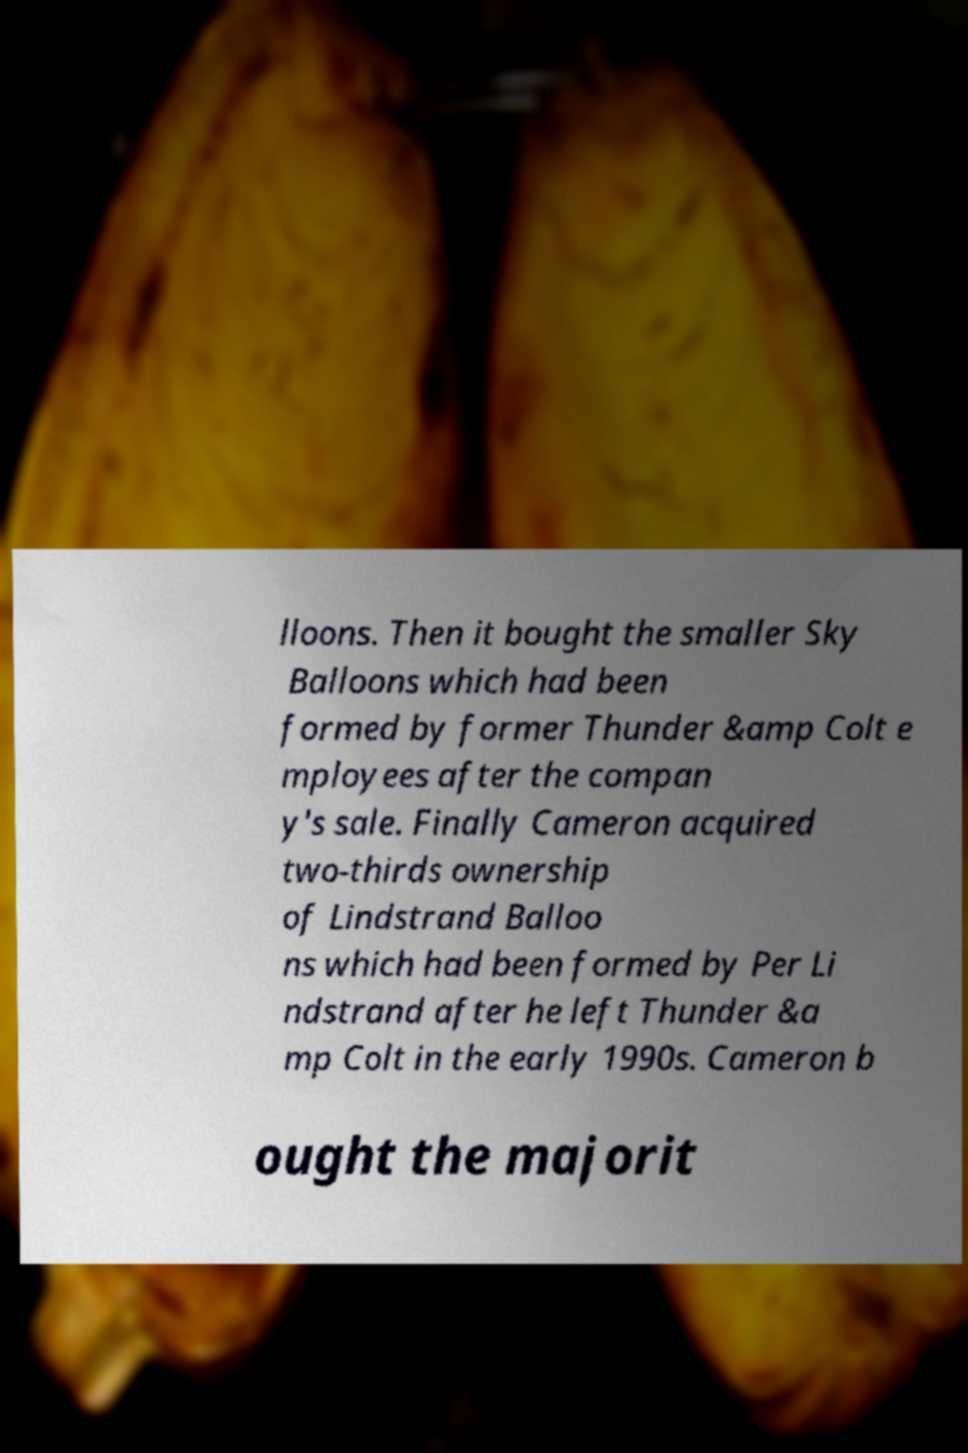Can you read and provide the text displayed in the image?This photo seems to have some interesting text. Can you extract and type it out for me? lloons. Then it bought the smaller Sky Balloons which had been formed by former Thunder &amp Colt e mployees after the compan y's sale. Finally Cameron acquired two-thirds ownership of Lindstrand Balloo ns which had been formed by Per Li ndstrand after he left Thunder &a mp Colt in the early 1990s. Cameron b ought the majorit 